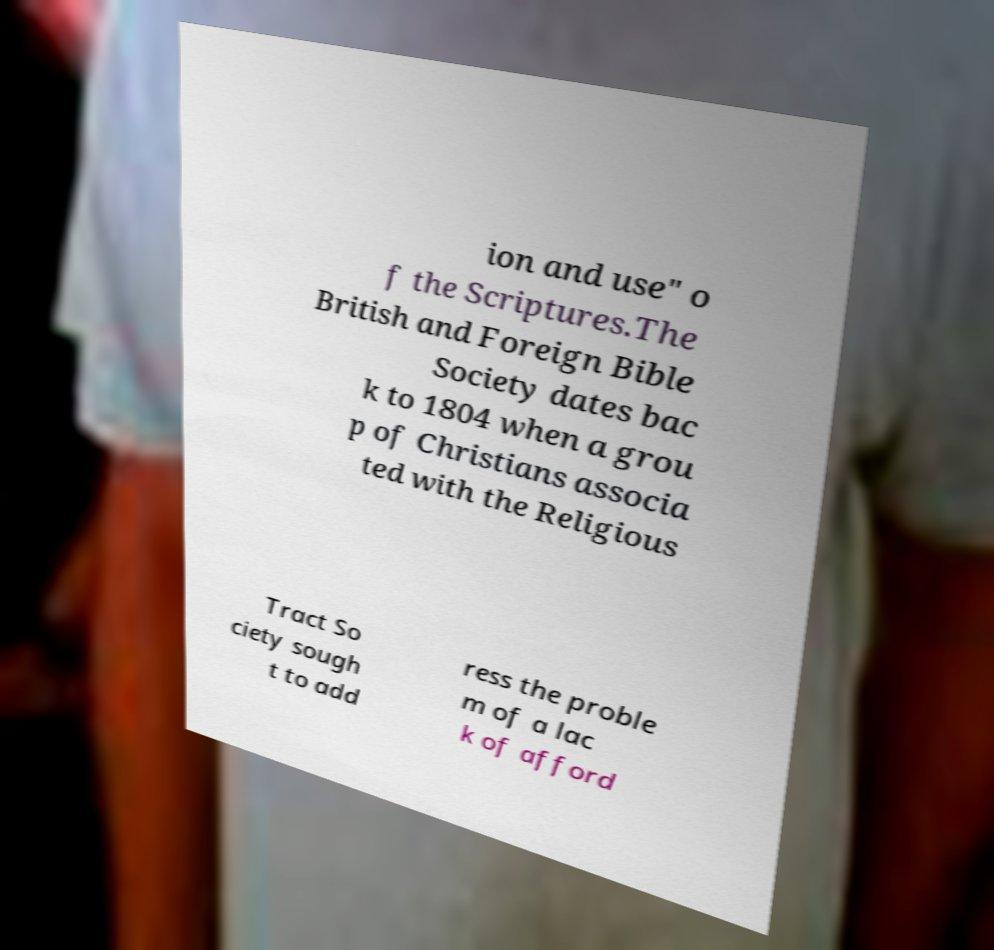What messages or text are displayed in this image? I need them in a readable, typed format. ion and use" o f the Scriptures.The British and Foreign Bible Society dates bac k to 1804 when a grou p of Christians associa ted with the Religious Tract So ciety sough t to add ress the proble m of a lac k of afford 